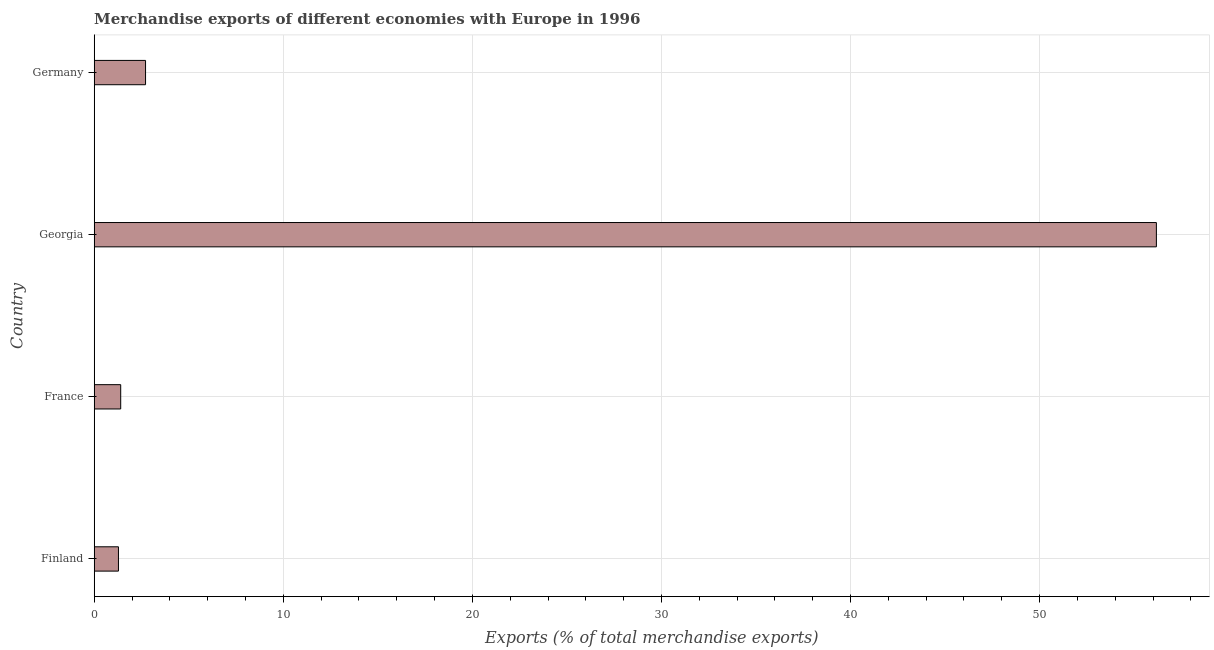Does the graph contain any zero values?
Keep it short and to the point. No. Does the graph contain grids?
Give a very brief answer. Yes. What is the title of the graph?
Make the answer very short. Merchandise exports of different economies with Europe in 1996. What is the label or title of the X-axis?
Provide a short and direct response. Exports (% of total merchandise exports). What is the label or title of the Y-axis?
Provide a succinct answer. Country. What is the merchandise exports in France?
Ensure brevity in your answer.  1.4. Across all countries, what is the maximum merchandise exports?
Keep it short and to the point. 56.18. Across all countries, what is the minimum merchandise exports?
Provide a short and direct response. 1.28. In which country was the merchandise exports maximum?
Make the answer very short. Georgia. In which country was the merchandise exports minimum?
Provide a short and direct response. Finland. What is the sum of the merchandise exports?
Your answer should be very brief. 61.58. What is the difference between the merchandise exports in France and Georgia?
Your answer should be very brief. -54.77. What is the average merchandise exports per country?
Provide a short and direct response. 15.39. What is the median merchandise exports?
Provide a succinct answer. 2.06. What is the ratio of the merchandise exports in France to that in Germany?
Keep it short and to the point. 0.52. Is the difference between the merchandise exports in France and Germany greater than the difference between any two countries?
Keep it short and to the point. No. What is the difference between the highest and the second highest merchandise exports?
Your answer should be very brief. 53.46. Is the sum of the merchandise exports in France and Germany greater than the maximum merchandise exports across all countries?
Provide a short and direct response. No. What is the difference between the highest and the lowest merchandise exports?
Make the answer very short. 54.89. In how many countries, is the merchandise exports greater than the average merchandise exports taken over all countries?
Your answer should be compact. 1. Are all the bars in the graph horizontal?
Make the answer very short. Yes. What is the difference between two consecutive major ticks on the X-axis?
Make the answer very short. 10. What is the Exports (% of total merchandise exports) of Finland?
Your answer should be very brief. 1.28. What is the Exports (% of total merchandise exports) of France?
Make the answer very short. 1.4. What is the Exports (% of total merchandise exports) in Georgia?
Provide a short and direct response. 56.18. What is the Exports (% of total merchandise exports) in Germany?
Keep it short and to the point. 2.72. What is the difference between the Exports (% of total merchandise exports) in Finland and France?
Provide a short and direct response. -0.12. What is the difference between the Exports (% of total merchandise exports) in Finland and Georgia?
Give a very brief answer. -54.89. What is the difference between the Exports (% of total merchandise exports) in Finland and Germany?
Provide a short and direct response. -1.43. What is the difference between the Exports (% of total merchandise exports) in France and Georgia?
Your response must be concise. -54.77. What is the difference between the Exports (% of total merchandise exports) in France and Germany?
Provide a short and direct response. -1.31. What is the difference between the Exports (% of total merchandise exports) in Georgia and Germany?
Offer a very short reply. 53.46. What is the ratio of the Exports (% of total merchandise exports) in Finland to that in France?
Your answer should be compact. 0.92. What is the ratio of the Exports (% of total merchandise exports) in Finland to that in Georgia?
Your answer should be compact. 0.02. What is the ratio of the Exports (% of total merchandise exports) in Finland to that in Germany?
Your answer should be compact. 0.47. What is the ratio of the Exports (% of total merchandise exports) in France to that in Georgia?
Your answer should be very brief. 0.03. What is the ratio of the Exports (% of total merchandise exports) in France to that in Germany?
Offer a very short reply. 0.52. What is the ratio of the Exports (% of total merchandise exports) in Georgia to that in Germany?
Provide a short and direct response. 20.69. 